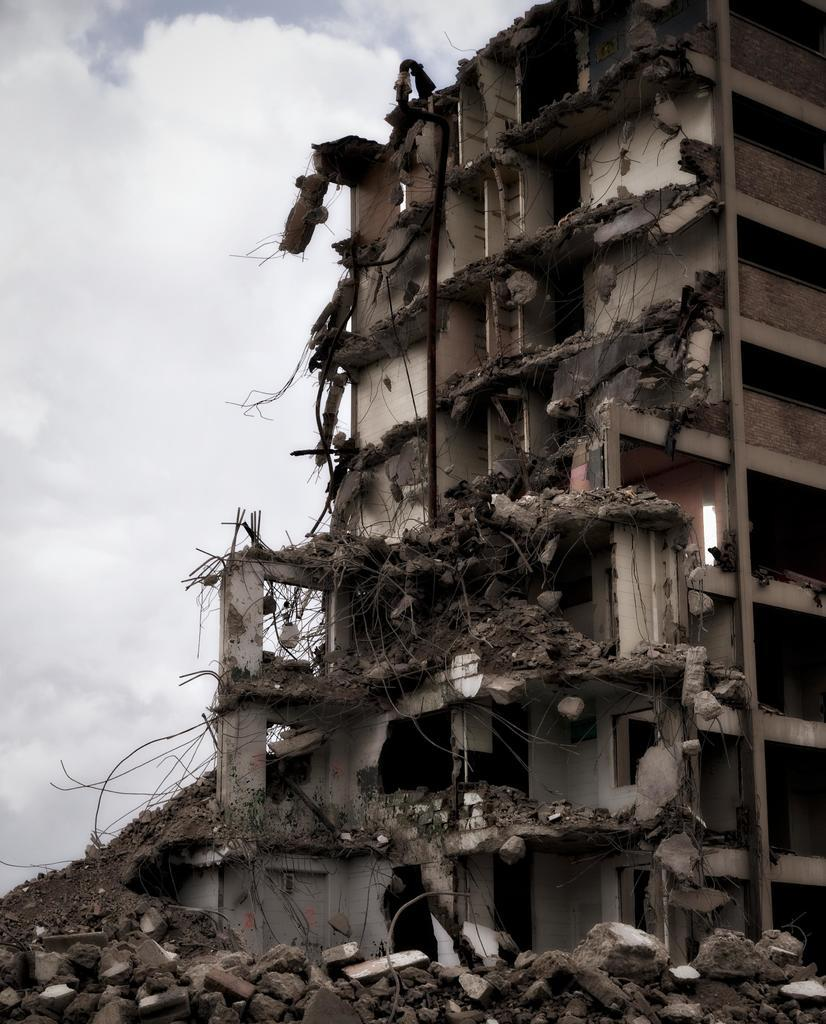What is the main subject of the image? The main subject of the image is a collapsed building. What can be seen in the background of the image? There are clouds in the sky in the background of the image. What is the taste of the clouds in the image? Clouds do not have a taste, as they are made of water vapor and are not edible. 